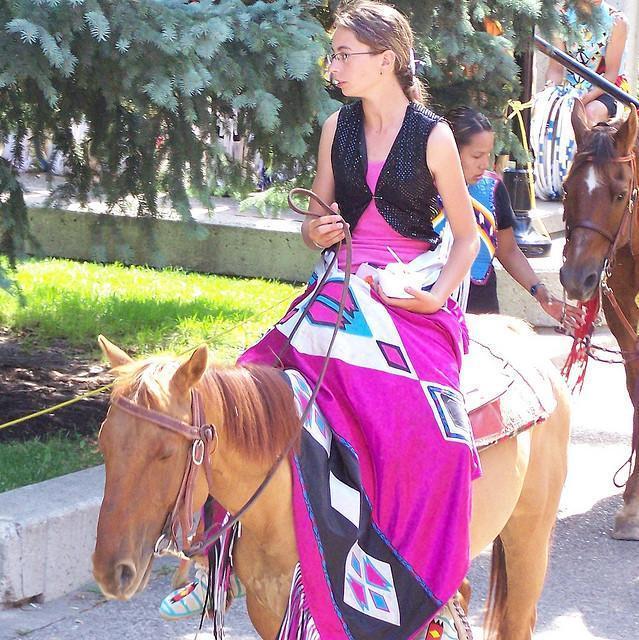How many horses are in the photo?
Give a very brief answer. 2. How many horses are in the picture?
Give a very brief answer. 2. How many people can be seen?
Give a very brief answer. 3. How many toilets are shown?
Give a very brief answer. 0. 